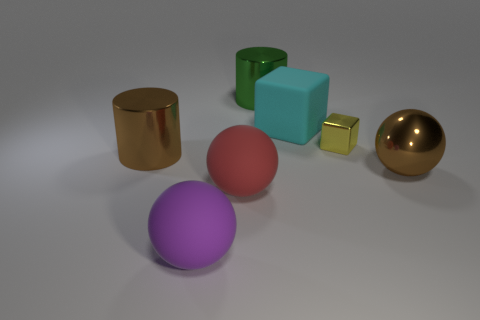Subtract all brown shiny balls. How many balls are left? 2 Add 2 green objects. How many objects exist? 9 Subtract all yellow spheres. Subtract all purple cylinders. How many spheres are left? 3 Add 5 red objects. How many red objects are left? 6 Add 3 large purple rubber cylinders. How many large purple rubber cylinders exist? 3 Subtract 1 red balls. How many objects are left? 6 Subtract all cubes. How many objects are left? 5 Subtract all large cyan cubes. Subtract all green cylinders. How many objects are left? 5 